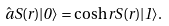<formula> <loc_0><loc_0><loc_500><loc_500>\hat { a } S ( r ) | 0 \rangle = \cosh r S ( r ) | 1 \rangle .</formula> 